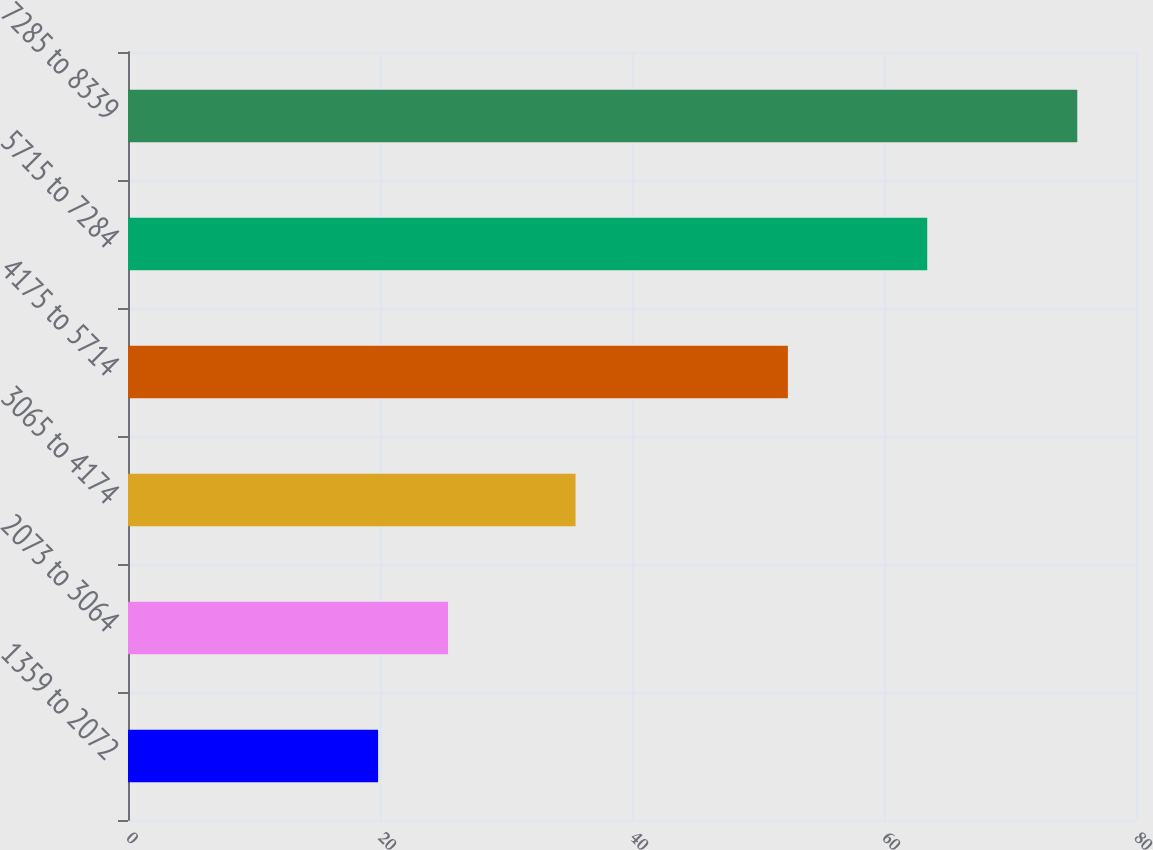Convert chart. <chart><loc_0><loc_0><loc_500><loc_500><bar_chart><fcel>1359 to 2072<fcel>2073 to 3064<fcel>3065 to 4174<fcel>4175 to 5714<fcel>5715 to 7284<fcel>7285 to 8339<nl><fcel>19.85<fcel>25.4<fcel>35.52<fcel>52.37<fcel>63.43<fcel>75.34<nl></chart> 